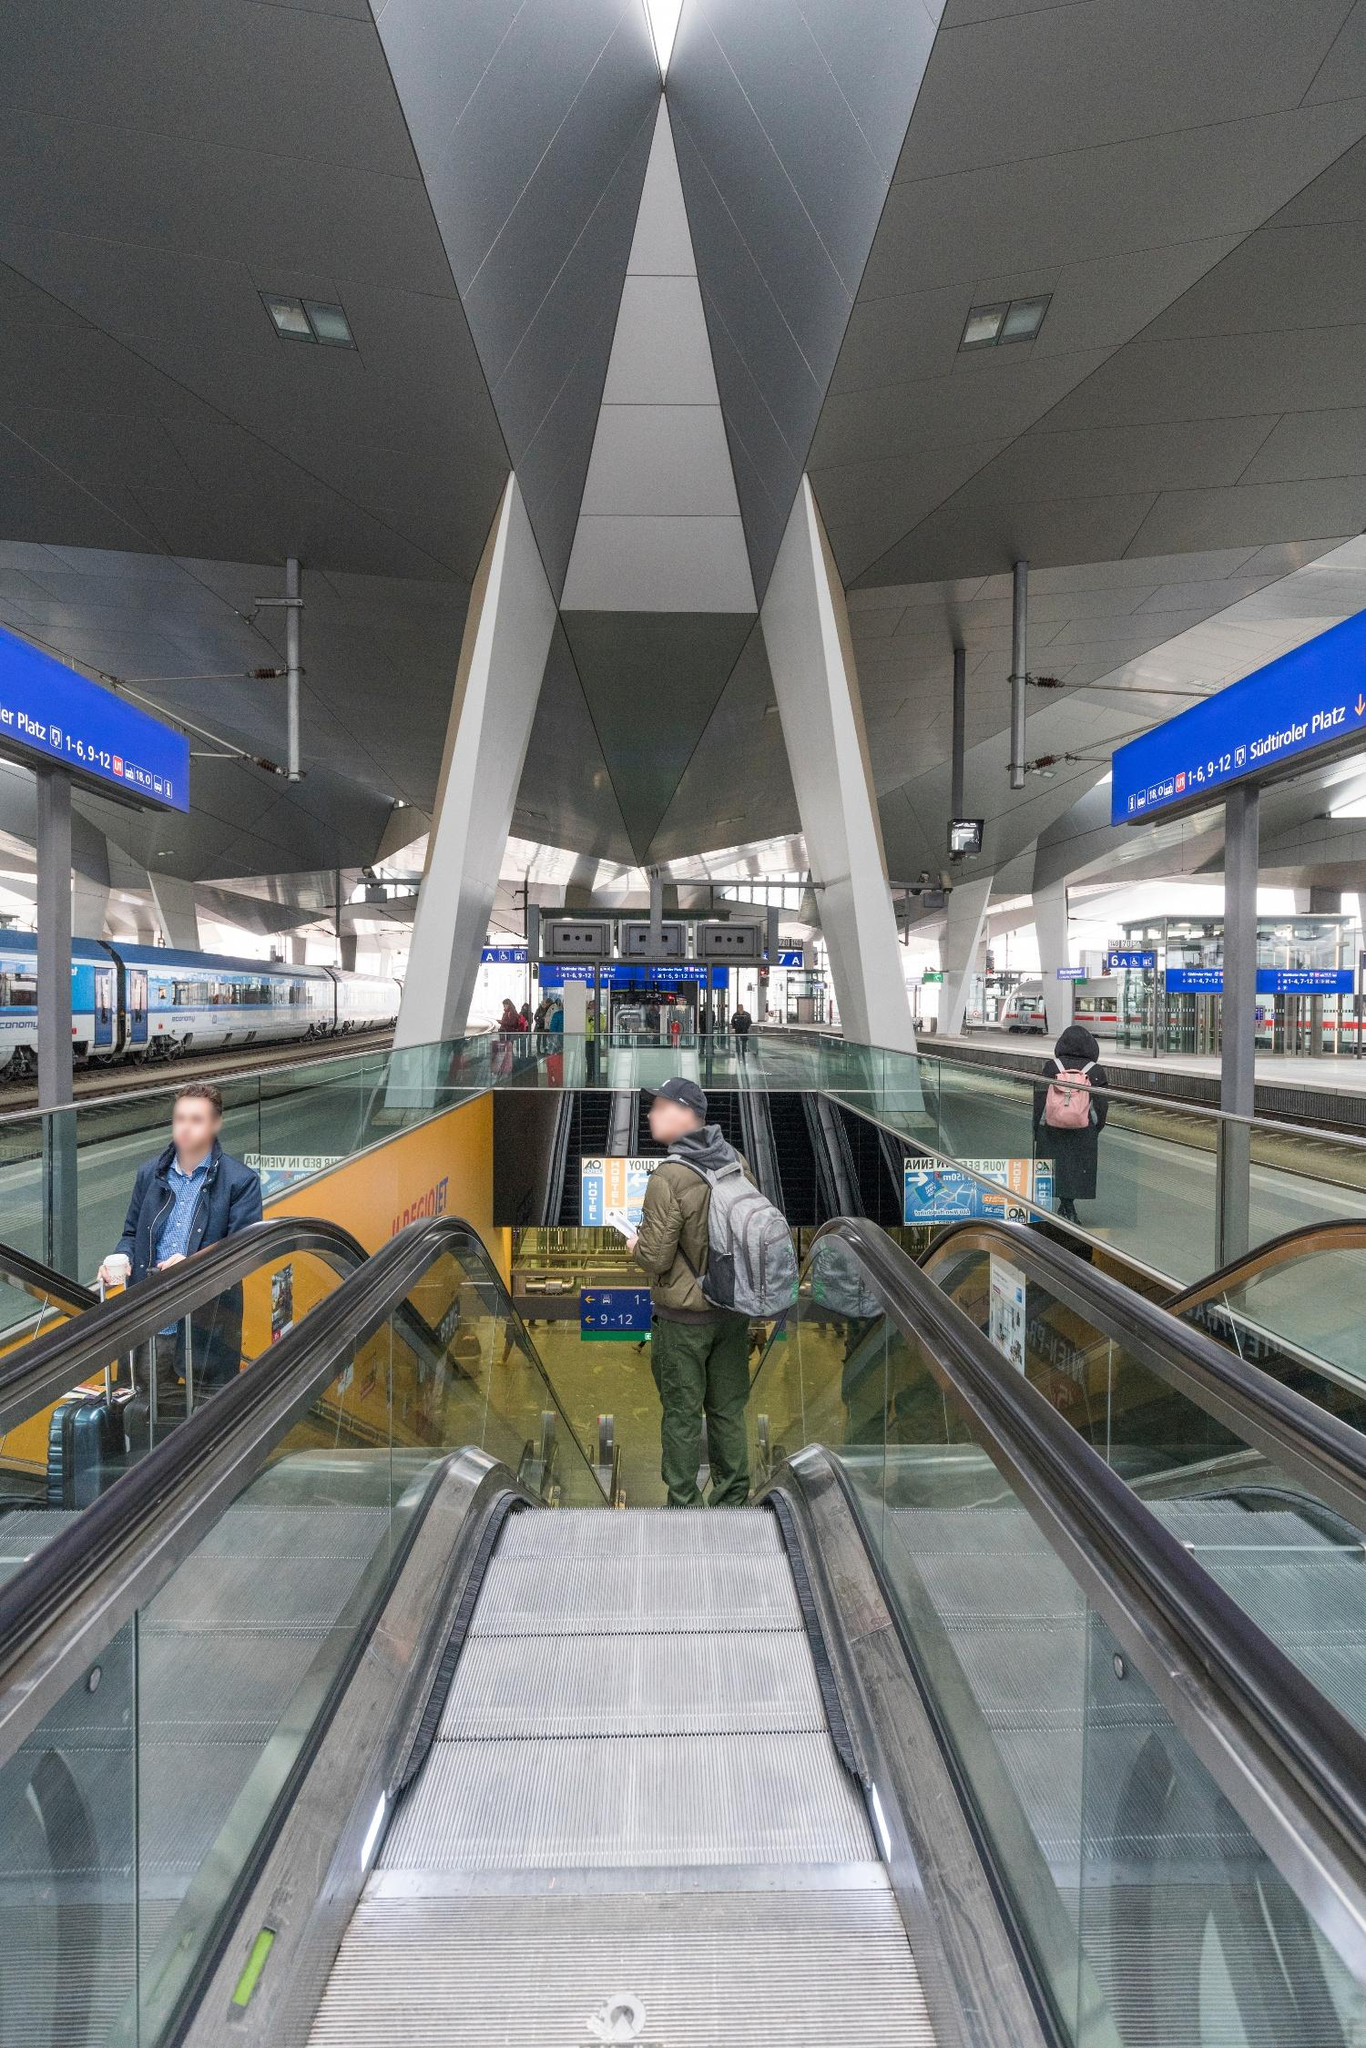What do the various signs and directions in this image indicate about the functionality of the station? The signs, prominently rendered in a vivid blue, serve crucial navigational purposes. For instance, they display platform numbers and cardinal directions ('E', 'W', 'N', 'S') to guide commuters efficiently to their intended destinations. The clarity and visibility of these signs reflect thoughtful design considerations aimed at enhancing user experience by minimizing confusion and ensuring smooth flow within a busy station. Such signage is essential, especially in a station that likely accommodates a significant number of daily passengers, helping them find their way quickly and safely. 